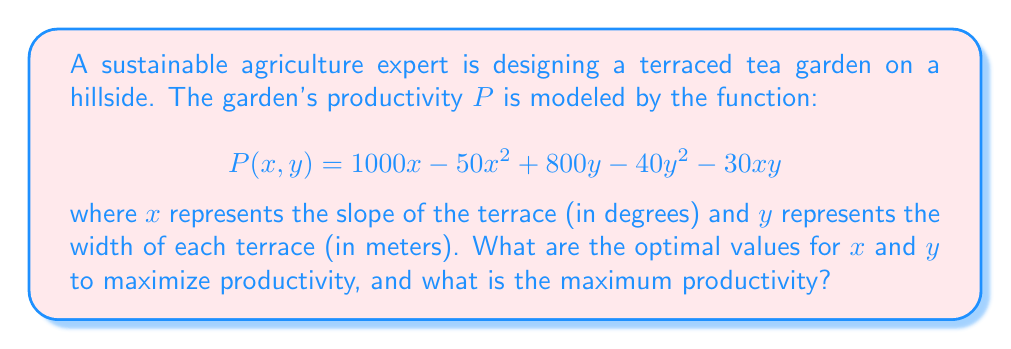Solve this math problem. To find the optimal values for $x$ and $y$ that maximize productivity, we need to use multivariable calculus. We'll follow these steps:

1) Find the partial derivatives of $P$ with respect to $x$ and $y$:

   $$\frac{\partial P}{\partial x} = 1000 - 100x - 30y$$
   $$\frac{\partial P}{\partial y} = 800 - 80y - 30x$$

2) Set both partial derivatives equal to zero to find critical points:

   $$1000 - 100x - 30y = 0 \quad (1)$$
   $$800 - 80y - 30x = 0 \quad (2)$$

3) Solve this system of equations:
   Multiply equation (1) by 4 and equation (2) by 5:

   $$4000 - 400x - 120y = 0 \quad (3)$$
   $$4000 - 400y - 150x = 0 \quad (4)$$

   Subtract equation (4) from (3):

   $$280y - 250x = 0$$
   $$y = \frac{25x}{28}$$

   Substitute this into equation (1):

   $$1000 - 100x - 30(\frac{25x}{28}) = 0$$
   $$1000 - 100x - \frac{750x}{28} = 0$$
   $$28000 - 2800x - 750x = 0$$
   $$28000 - 3550x = 0$$
   $$x = \frac{28000}{3550} = \frac{560}{71} \approx 7.89$$

   Now substitute back to find y:

   $$y = \frac{25}{28} \cdot \frac{560}{71} = \frac{500}{71} \approx 7.04$$

4) To confirm this is a maximum, we need to check the second partial derivatives:

   $$\frac{\partial^2 P}{\partial x^2} = -100$$
   $$\frac{\partial^2 P}{\partial y^2} = -80$$
   $$\frac{\partial^2 P}{\partial x \partial y} = \frac{\partial^2 P}{\partial y \partial x} = -30$$

   The Hessian matrix is:
   $$H = \begin{bmatrix} -100 & -30 \\ -30 & -80 \end{bmatrix}$$

   The determinant of H is positive (7000 > 0) and $\frac{\partial^2 P}{\partial x^2} < 0$, confirming a local maximum.

5) Calculate the maximum productivity:

   $$P(\frac{560}{71}, \frac{500}{71}) = 1000(\frac{560}{71}) - 50(\frac{560}{71})^2 + 800(\frac{500}{71}) - 40(\frac{500}{71})^2 - 30(\frac{560}{71})(\frac{500}{71})$$

   $$\approx 7890 - 3110 + 5634 - 1974 - 1667 \approx 6773$$
Answer: Optimal slope: $\frac{560}{71}^\circ \approx 7.89^\circ$, Optimal width: $\frac{500}{71}$ m $\approx 7.04$ m, Maximum productivity: 6773 units 